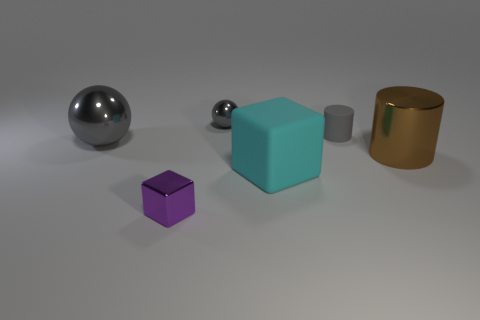What number of other objects are there of the same material as the small cylinder?
Your answer should be compact. 1. How many matte objects are spheres or blue things?
Offer a very short reply. 0. Do the gray thing that is on the left side of the metallic cube and the small gray metallic thing have the same shape?
Your response must be concise. Yes. Is the number of cubes in front of the big rubber thing greater than the number of red matte cylinders?
Provide a succinct answer. Yes. What number of big things are to the left of the tiny cylinder and right of the small gray sphere?
Offer a terse response. 1. What is the color of the tiny object that is on the right side of the gray ball that is to the right of the tiny cube?
Your answer should be very brief. Gray. How many small things are the same color as the matte cylinder?
Make the answer very short. 1. There is a tiny matte cylinder; does it have the same color as the tiny shiny object that is behind the gray cylinder?
Ensure brevity in your answer.  Yes. Is the number of cyan blocks less than the number of large cyan balls?
Provide a succinct answer. No. Are there more large cyan matte cubes behind the metal cylinder than tiny purple things in front of the purple metal thing?
Give a very brief answer. No. 